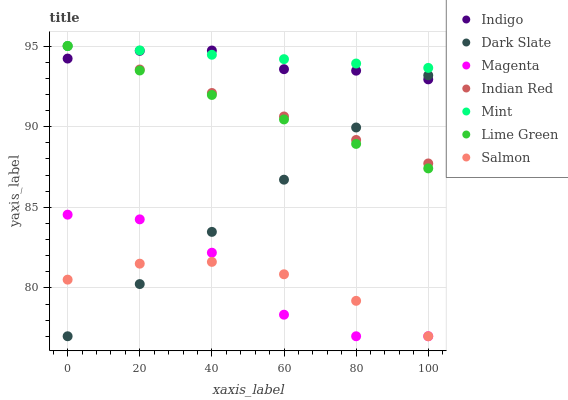Does Salmon have the minimum area under the curve?
Answer yes or no. Yes. Does Mint have the maximum area under the curve?
Answer yes or no. Yes. Does Mint have the minimum area under the curve?
Answer yes or no. No. Does Salmon have the maximum area under the curve?
Answer yes or no. No. Is Mint the smoothest?
Answer yes or no. Yes. Is Magenta the roughest?
Answer yes or no. Yes. Is Salmon the smoothest?
Answer yes or no. No. Is Salmon the roughest?
Answer yes or no. No. Does Salmon have the lowest value?
Answer yes or no. Yes. Does Mint have the lowest value?
Answer yes or no. No. Does Lime Green have the highest value?
Answer yes or no. Yes. Does Salmon have the highest value?
Answer yes or no. No. Is Magenta less than Mint?
Answer yes or no. Yes. Is Indigo greater than Magenta?
Answer yes or no. Yes. Does Indian Red intersect Mint?
Answer yes or no. Yes. Is Indian Red less than Mint?
Answer yes or no. No. Is Indian Red greater than Mint?
Answer yes or no. No. Does Magenta intersect Mint?
Answer yes or no. No. 